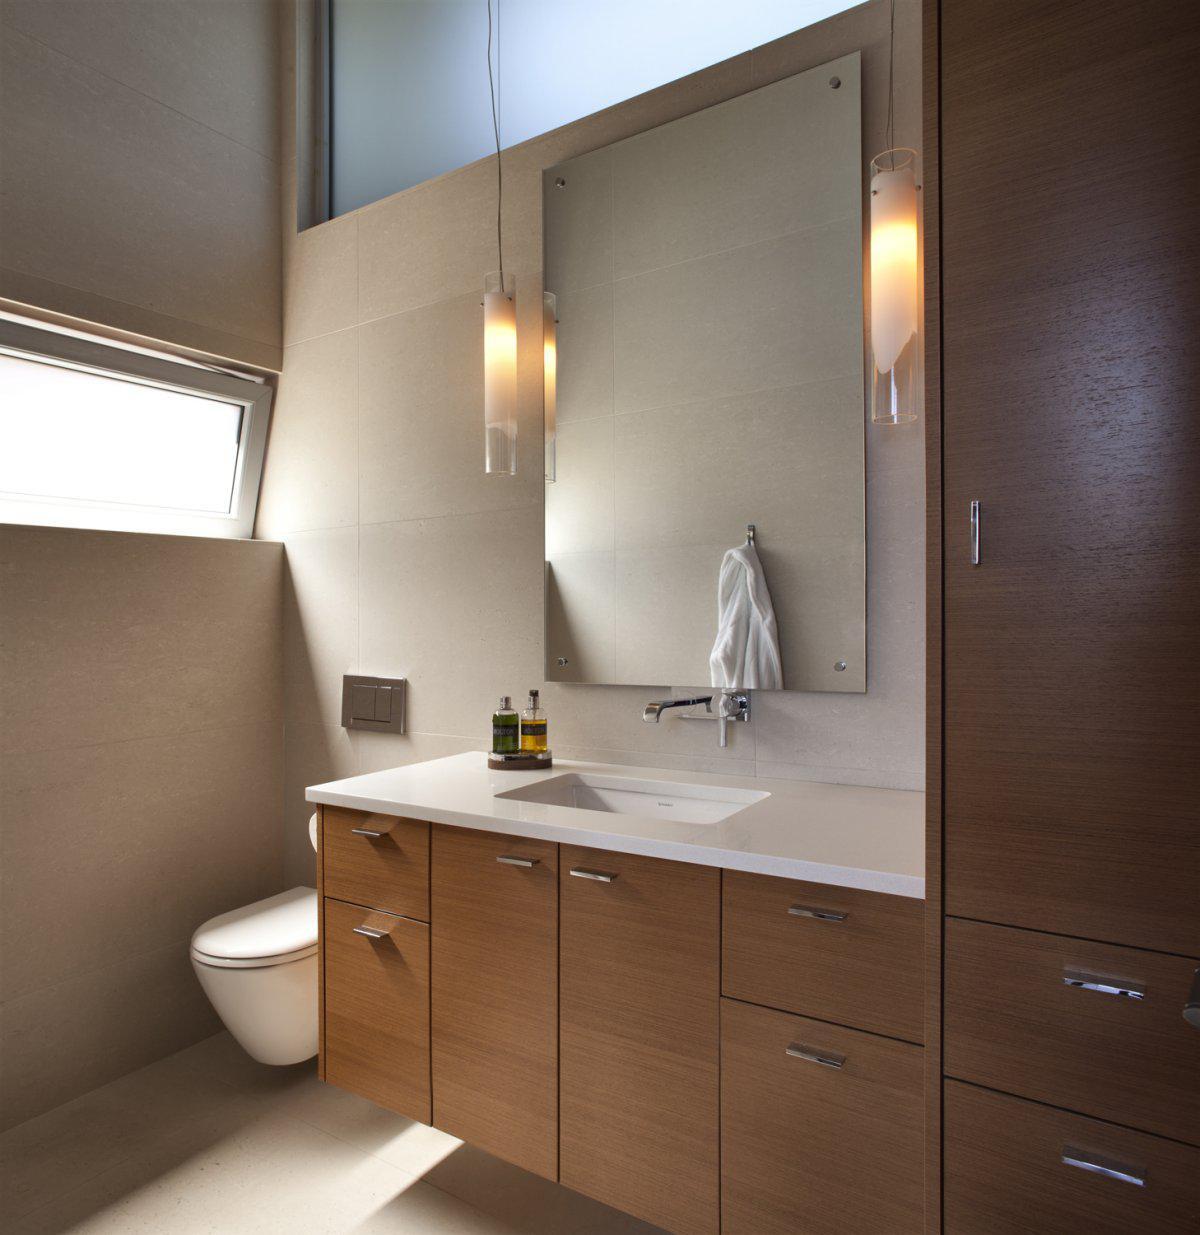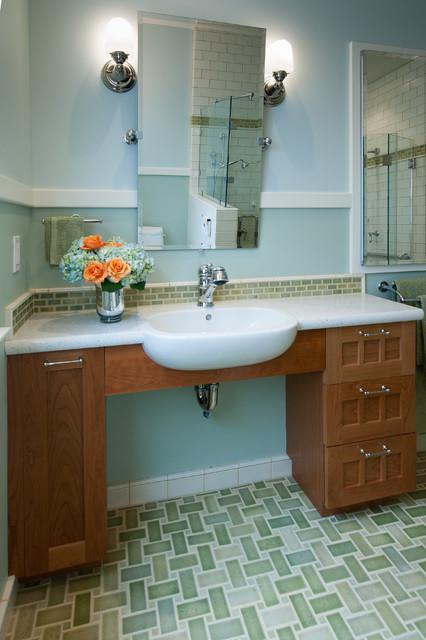The first image is the image on the left, the second image is the image on the right. Considering the images on both sides, is "Both image show a sink and vanity, but only one image has a rectangular sink basin." valid? Answer yes or no. Yes. 